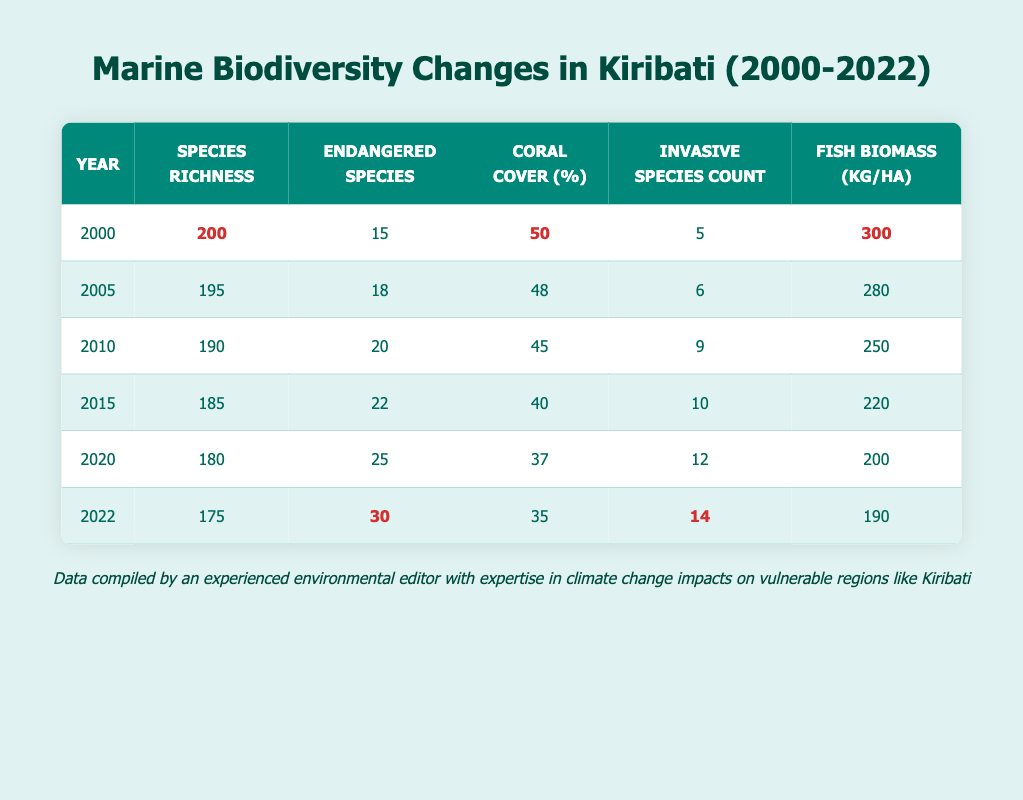How many species were recorded in 2000? Referring to the table, the number of species recorded in 2000 is directly shown in the "Species Richness" column for that year. It is 200 species.
Answer: 200 What was the percentage of coral cover in 2015? The table shows the "Coral Cover (%)" for each year, and for 2015, it is listed as 40%.
Answer: 40% Which year saw the highest number of endangered species? By examining the "Endangered Species" column, we find that 2022 has the highest number of endangered species, with a count of 30.
Answer: 2022 How much did fish biomass decrease from 2000 to 2022? In 2000, the fish biomass was 300 kg/ha; in 2022 it is 190 kg/ha. The decrease can be calculated as 300 - 190 = 110 kg/ha.
Answer: 110 kg/ha What is the average number of invasive species from 2000 to 2022? The number of invasive species over the years is 5, 6, 9, 10, 12, and 14. The sum of these values is 56 and there are 6 data points. The average is therefore 56/6 ≈ 9.33.
Answer: 9.33 Was there an increase in the number of endangered species between 2010 and 2015? In 2010, the count of endangered species was 20, increasing to 22 in 2015. Therefore, there was an increase.
Answer: Yes What is the trend in species richness from 2000 to 2022? By observing the "Species Richness" column from 2000 (200 species) to 2022 (175 species), we see a consistent decline over the years, confirming a negative trend.
Answer: Declining Which year had the lowest coral cover percentage? The table indicates that in 2022, the coral cover percentage dropped to 35%, which is the lowest percentage recorded.
Answer: 2022 Calculate the total number of endangered species from 2000 to 2022. The endangered species counts over the years are: 15 (2000), 18 (2005), 20 (2010), 22 (2015), 25 (2020), and 30 (2022). Summing them gives: 15 + 18 + 20 + 22 + 25 + 30 = 130.
Answer: 130 In what year was the fish biomass the highest? Looking at the "Fish Biomass (kg/ha)" column, 2000 has the highest recorded fish biomass at 300 kg/ha.
Answer: 2000 